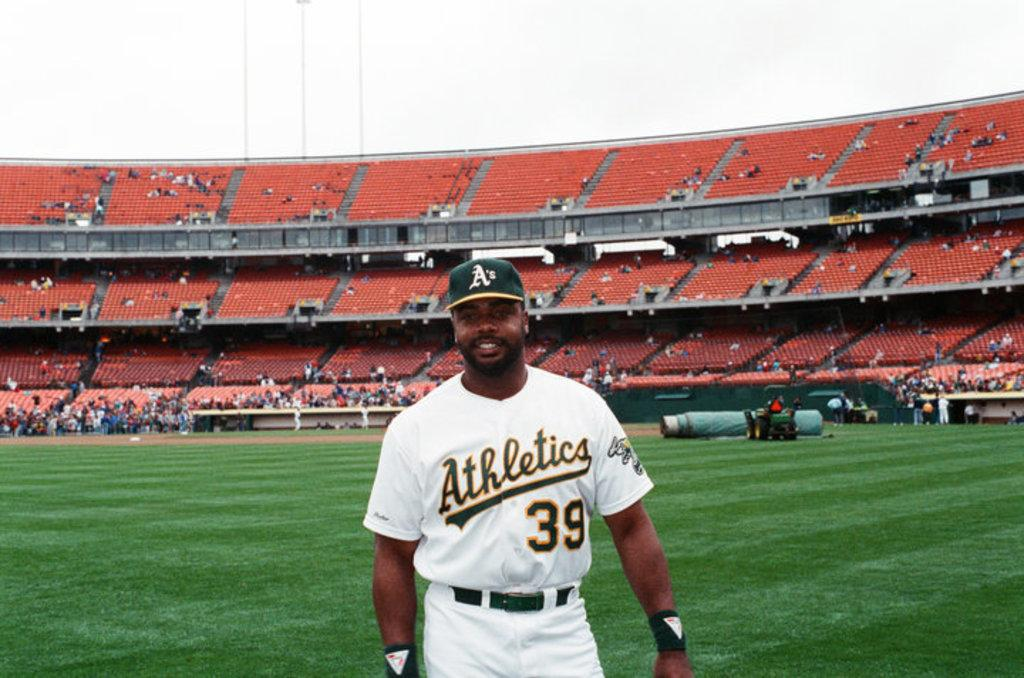<image>
Give a short and clear explanation of the subsequent image. a oakland a player wearing a white athletic jersey number 39 